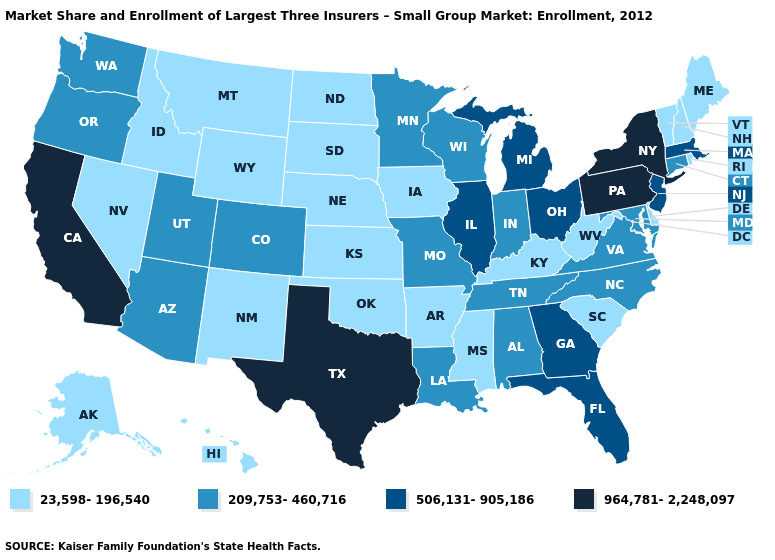Is the legend a continuous bar?
Be succinct. No. What is the lowest value in states that border Missouri?
Answer briefly. 23,598-196,540. Name the states that have a value in the range 23,598-196,540?
Short answer required. Alaska, Arkansas, Delaware, Hawaii, Idaho, Iowa, Kansas, Kentucky, Maine, Mississippi, Montana, Nebraska, Nevada, New Hampshire, New Mexico, North Dakota, Oklahoma, Rhode Island, South Carolina, South Dakota, Vermont, West Virginia, Wyoming. What is the lowest value in states that border Mississippi?
Write a very short answer. 23,598-196,540. What is the lowest value in states that border Tennessee?
Give a very brief answer. 23,598-196,540. What is the value of California?
Quick response, please. 964,781-2,248,097. Does Alaska have the lowest value in the USA?
Answer briefly. Yes. What is the highest value in the South ?
Concise answer only. 964,781-2,248,097. Name the states that have a value in the range 964,781-2,248,097?
Answer briefly. California, New York, Pennsylvania, Texas. What is the value of Texas?
Be succinct. 964,781-2,248,097. Does the map have missing data?
Keep it brief. No. What is the highest value in the USA?
Concise answer only. 964,781-2,248,097. What is the value of Utah?
Write a very short answer. 209,753-460,716. What is the value of Ohio?
Answer briefly. 506,131-905,186. Does Maine have a lower value than Texas?
Short answer required. Yes. 